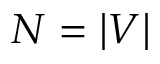Convert formula to latex. <formula><loc_0><loc_0><loc_500><loc_500>N = | V |</formula> 